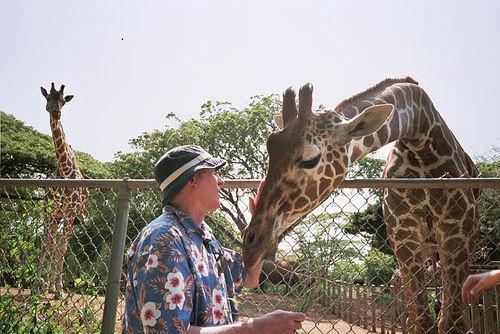How many giraffes are interacting with the man? one 